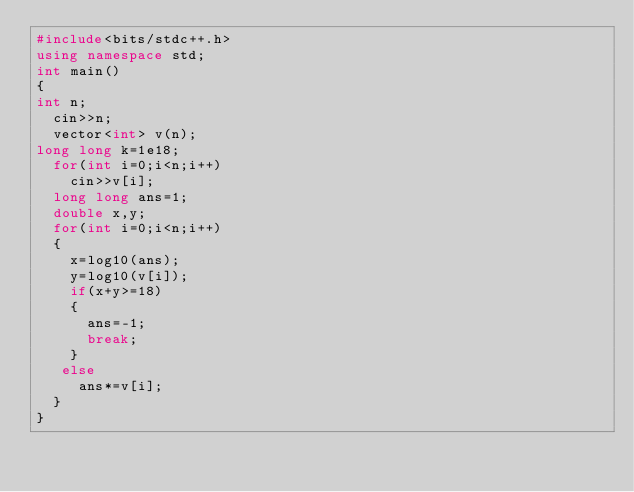<code> <loc_0><loc_0><loc_500><loc_500><_C++_>#include<bits/stdc++.h>
using namespace std;
int main()
{
int n;
  cin>>n;
  vector<int> v(n);
long long k=1e18;
  for(int i=0;i<n;i++)
    cin>>v[i];
  long long ans=1;
  double x,y;
  for(int i=0;i<n;i++)
  {
    x=log10(ans);
    y=log10(v[i]);
    if(x+y>=18)
    {
      ans=-1;
      break;
    }
   else
     ans*=v[i];
  }
}
</code> 